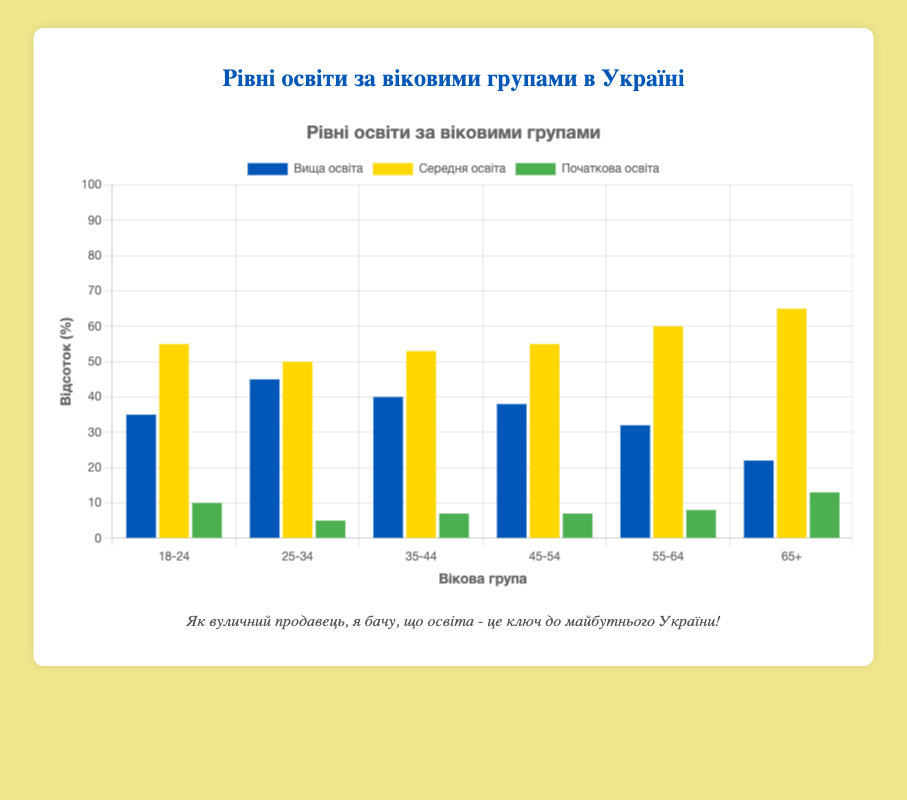Which age group has the highest percentage of higher education? Looking at the bars for higher education, the tallest bar corresponds to the age group 25-34. This bar is higher compared to other age groups.
Answer: 25-34 Which age group has the lowest percentage of primary education? The bar for primary education is the shortest for the age group 25-34. This indicates that this group has the lowest percentage of primary education.
Answer: 25-34 What is the combined percentage of secondary and primary education for the age group 65+? For the age group 65+, the percentage of secondary education is 65 and primary education is 13. Summing these two gives 65 + 13 = 78.
Answer: 78 Compare the percentages of higher education between the age groups 35-44 and 45-54. Which one is higher? The bars for higher education show that the age group 35-44 has a 40% while the age group 45-54 has a 38%. Therefore, 35-44 has a higher percentage.
Answer: 35-44 Which age group has the most evenly distributed levels of education? To find the most even distribution, we look for the age group where the bar lengths are closest in height. The age group 18-24 has higher education 35%, secondary education 55%, and primary education 10%. This shows a more even distribution of education levels.
Answer: 18-24 What is the difference in the percentage of secondary education between the age groups 18-24 and 55-64? For the age group 18-24, the percentage is 55%, and for the 55-64 group, it is 60%. The difference is 60 - 55 = 5.
Answer: 5 Which education level has the largest positive trend as age increases? By comparing the trends across age groups, secondary education shows an overall increasing trend from 55% in the 18-24 age group to 65% in the 65+ group.
Answer: Secondary education In which age group is the percentage of primary education highest? The tallest bar for primary education corresponds to the age group 65+ with 13%.
Answer: 65+ What is the average percentage of higher education across all age groups? Adding the percentages of higher education: 35 + 45 + 40 + 38 + 32 + 22 = 212. Dividing by the number of age groups, 212 / 6 ≈ 35.33.
Answer: 35.33 